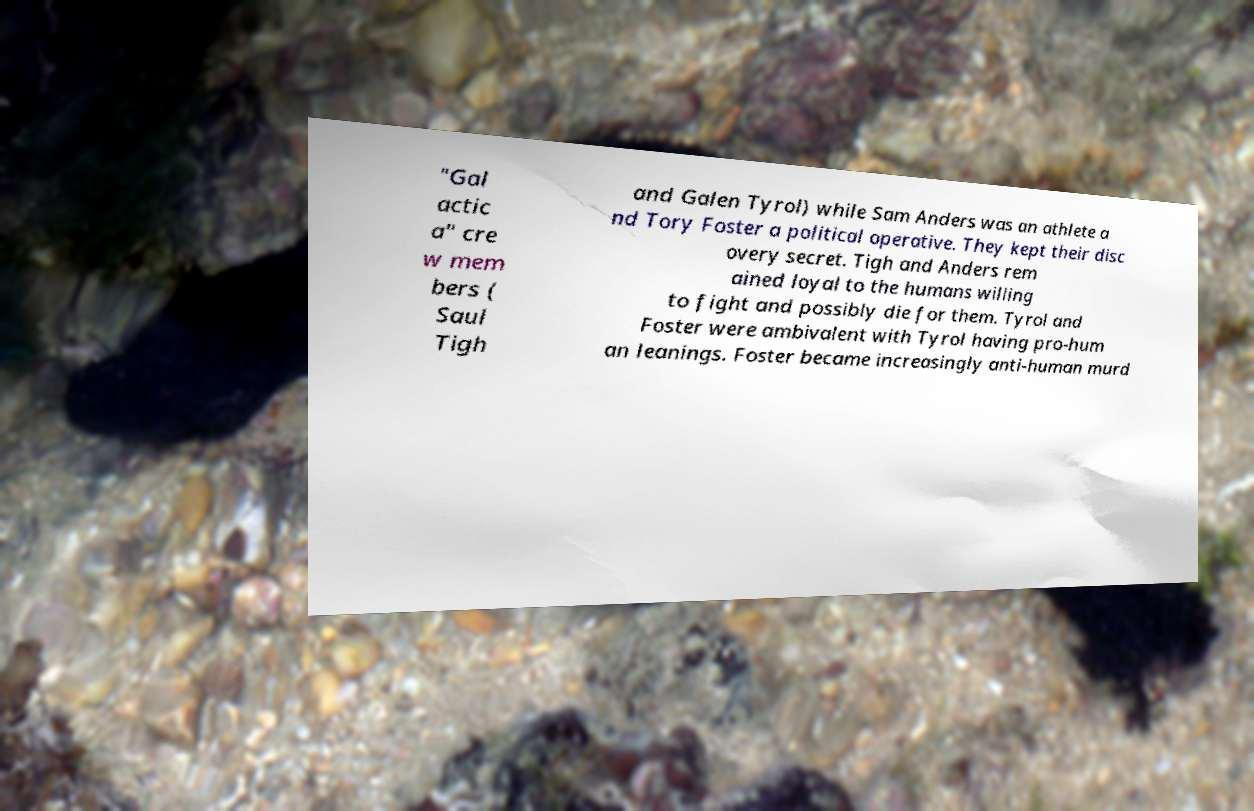Could you assist in decoding the text presented in this image and type it out clearly? "Gal actic a" cre w mem bers ( Saul Tigh and Galen Tyrol) while Sam Anders was an athlete a nd Tory Foster a political operative. They kept their disc overy secret. Tigh and Anders rem ained loyal to the humans willing to fight and possibly die for them. Tyrol and Foster were ambivalent with Tyrol having pro-hum an leanings. Foster became increasingly anti-human murd 